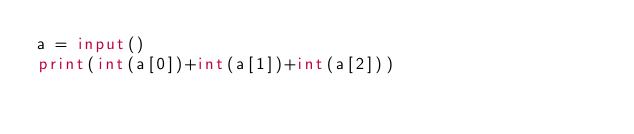<code> <loc_0><loc_0><loc_500><loc_500><_Python_>a = input()
print(int(a[0])+int(a[1])+int(a[2]))</code> 